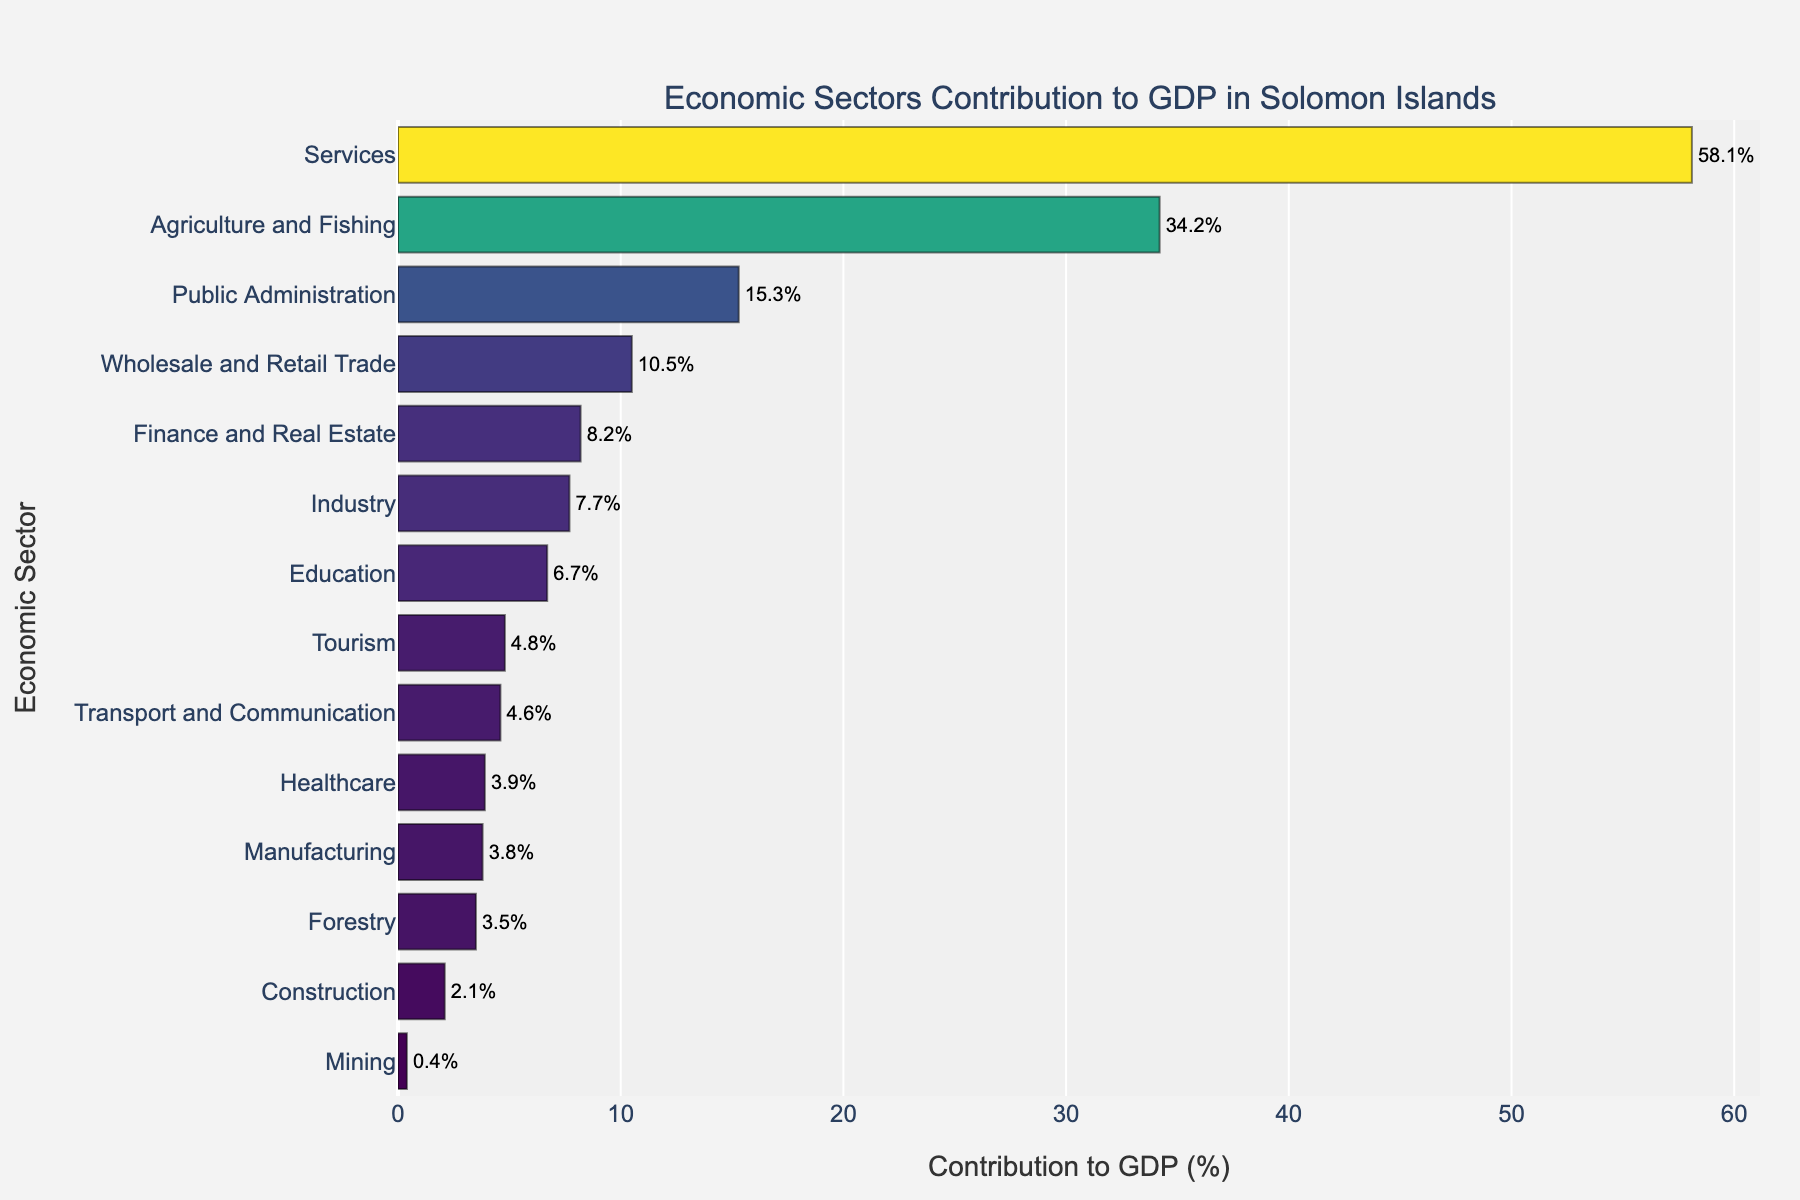Which sector has the highest contribution to GDP? By examining the bar chart, the sector with the longest bar represents the highest contribution. The Services sector has the longest bar with 58.1%.
Answer: Services Which sector has the lowest contribution to GDP? By looking for the shortest bar in the chart, the sector with the least contribution is identified. The Mining sector has the shortest bar with 0.4%.
Answer: Mining What is the combined contribution of Agriculture and Fishing, Industry, Forestry, and Manufacturing to the GDP? To find the combined contribution, sum the percentages of these sectors: Agriculture and Fishing (34.2%), Industry (7.7%), Forestry (3.5%), and Manufacturing (3.8%). The sum is 34.2 + 7.7 + 3.5 + 3.8 = 49.2%.
Answer: 49.2% Which sectors have a contribution greater than 10%? By examining the chart, the sectors with bars longer than the 10% mark are notable. These sectors are Services (58.1%), Agriculture and Fishing (34.2%), and Wholesale and Retail Trade (10.5%).
Answer: Services, Agriculture and Fishing, Wholesale and Retail Trade How much greater is the contribution of Services compared to Public Administration? Subtract the contribution of Public Administration (15.3%) from Services (58.1%). 58.1% - 15.3% = 42.8%.
Answer: 42.8% What is the average contribution of the Education, Healthcare, and Tourism sectors? Find the average by summing their percentages and dividing by the number of sectors: (Education 6.7% + Healthcare 3.9% + Tourism 4.8%) / 3 = 15.4 / 3 = 5.13%.
Answer: 5.1% Which sector contributes more to the GDP, Finance and Real Estate or Construction? By comparing the lengths of their bars, Finance and Real Estate (8.2%) contributes more than Construction (2.1%).
Answer: Finance and Real Estate What is the median contribution of all sectors? First, all sectors' contributions are sorted (0.4, 2.1, 3.5, 3.8, 3.9, 4.6, 4.8, 6.7, 7.7, 8.2, 10.5, 15.3, 34.2, 58.1). With an even number of values (14), the median is the average of the 7th and 8th values: (4.8 + 6.7) / 2 = 5.75%.
Answer: 5.75% What is the difference between the contribution of Transport and Communication, and Forestry? Subtract the contribution of Forestry (3.5%) from Transport and Communication (4.6%). 4.6% - 3.5% = 1.1%.
Answer: 1.1% What is the total contribution of the top three sectors? The top three sectors are Services (58.1%), Agriculture and Fishing (34.2%), and Public Administration (15.3%). The total contribution is 58.1 + 34.2 + 15.3 = 107.6%.
Answer: 107.6% 